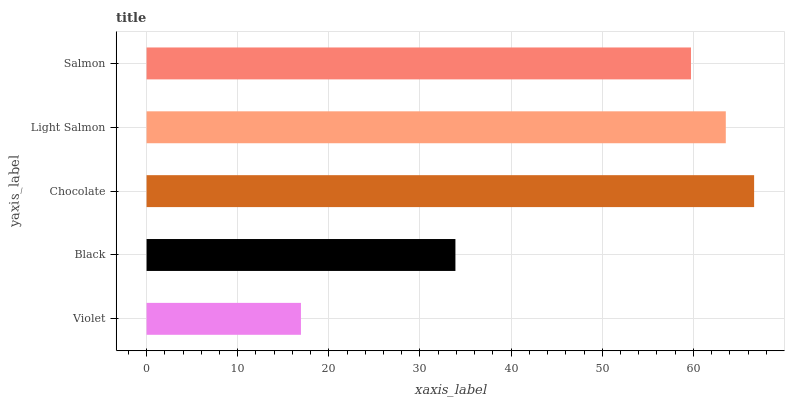Is Violet the minimum?
Answer yes or no. Yes. Is Chocolate the maximum?
Answer yes or no. Yes. Is Black the minimum?
Answer yes or no. No. Is Black the maximum?
Answer yes or no. No. Is Black greater than Violet?
Answer yes or no. Yes. Is Violet less than Black?
Answer yes or no. Yes. Is Violet greater than Black?
Answer yes or no. No. Is Black less than Violet?
Answer yes or no. No. Is Salmon the high median?
Answer yes or no. Yes. Is Salmon the low median?
Answer yes or no. Yes. Is Light Salmon the high median?
Answer yes or no. No. Is Light Salmon the low median?
Answer yes or no. No. 